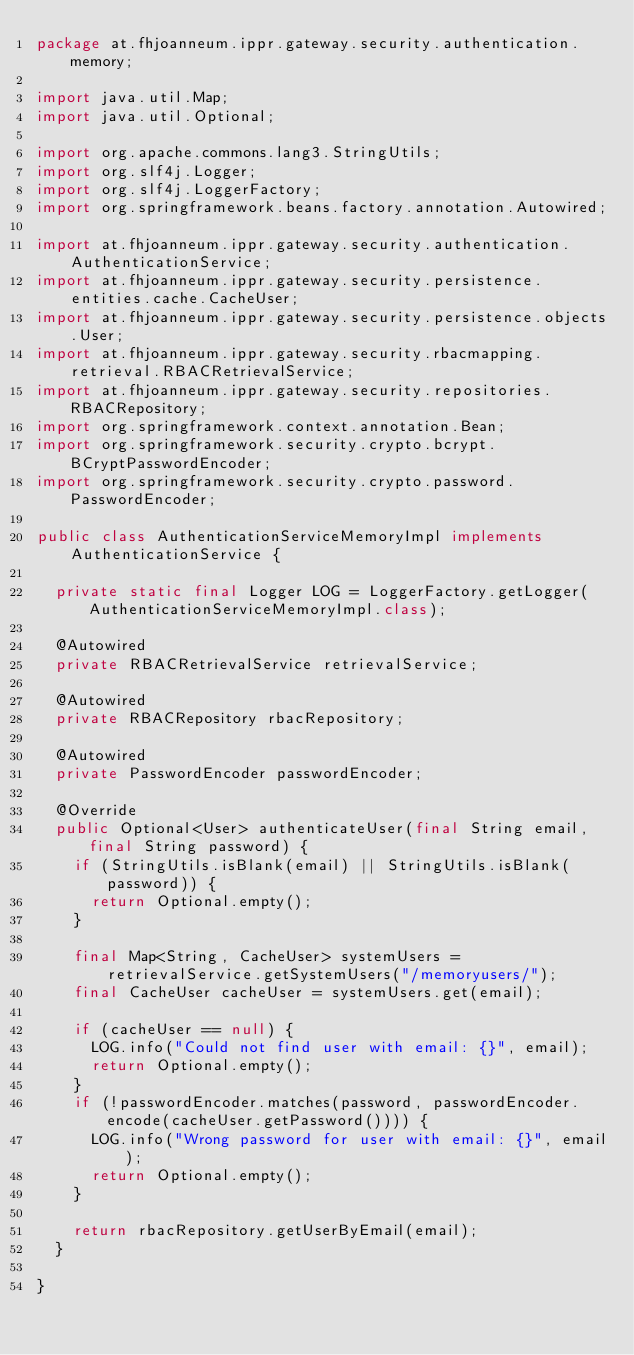<code> <loc_0><loc_0><loc_500><loc_500><_Java_>package at.fhjoanneum.ippr.gateway.security.authentication.memory;

import java.util.Map;
import java.util.Optional;

import org.apache.commons.lang3.StringUtils;
import org.slf4j.Logger;
import org.slf4j.LoggerFactory;
import org.springframework.beans.factory.annotation.Autowired;

import at.fhjoanneum.ippr.gateway.security.authentication.AuthenticationService;
import at.fhjoanneum.ippr.gateway.security.persistence.entities.cache.CacheUser;
import at.fhjoanneum.ippr.gateway.security.persistence.objects.User;
import at.fhjoanneum.ippr.gateway.security.rbacmapping.retrieval.RBACRetrievalService;
import at.fhjoanneum.ippr.gateway.security.repositories.RBACRepository;
import org.springframework.context.annotation.Bean;
import org.springframework.security.crypto.bcrypt.BCryptPasswordEncoder;
import org.springframework.security.crypto.password.PasswordEncoder;

public class AuthenticationServiceMemoryImpl implements AuthenticationService {

  private static final Logger LOG = LoggerFactory.getLogger(AuthenticationServiceMemoryImpl.class);

  @Autowired
  private RBACRetrievalService retrievalService;

  @Autowired
  private RBACRepository rbacRepository;

  @Autowired
  private PasswordEncoder passwordEncoder;

  @Override
  public Optional<User> authenticateUser(final String email, final String password) {
    if (StringUtils.isBlank(email) || StringUtils.isBlank(password)) {
      return Optional.empty();
    }

    final Map<String, CacheUser> systemUsers = retrievalService.getSystemUsers("/memoryusers/");
    final CacheUser cacheUser = systemUsers.get(email);

    if (cacheUser == null) {
      LOG.info("Could not find user with email: {}", email);
      return Optional.empty();
    }
    if (!passwordEncoder.matches(password, passwordEncoder.encode(cacheUser.getPassword()))) {
      LOG.info("Wrong password for user with email: {}", email);
      return Optional.empty();
    }

    return rbacRepository.getUserByEmail(email);
  }

}
</code> 